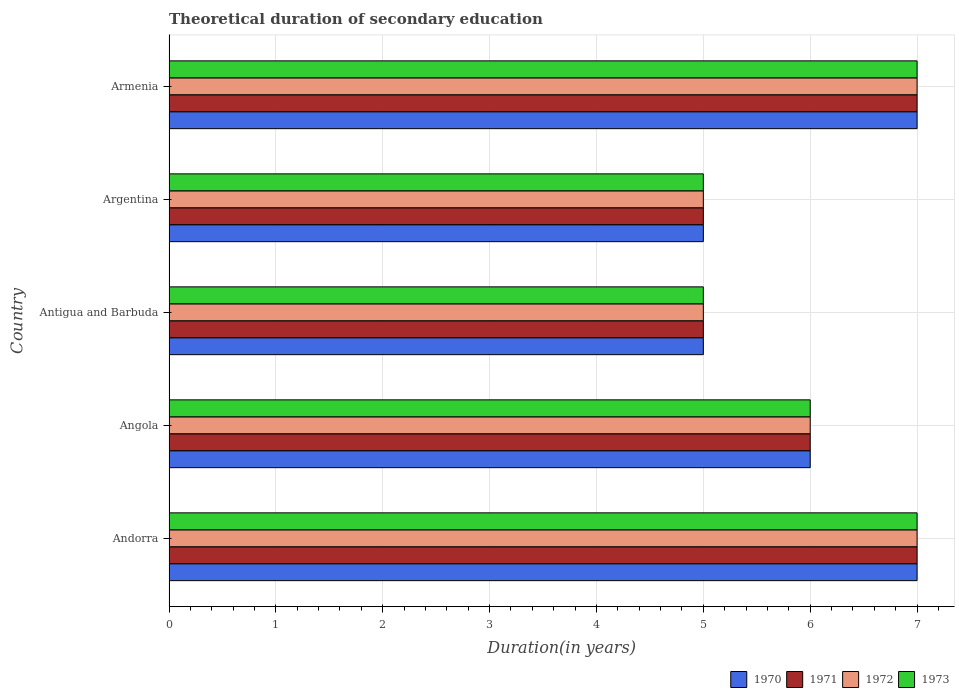How many different coloured bars are there?
Give a very brief answer. 4. How many groups of bars are there?
Your answer should be compact. 5. Are the number of bars on each tick of the Y-axis equal?
Provide a succinct answer. Yes. How many bars are there on the 5th tick from the bottom?
Ensure brevity in your answer.  4. What is the label of the 3rd group of bars from the top?
Provide a short and direct response. Antigua and Barbuda. Across all countries, what is the minimum total theoretical duration of secondary education in 1972?
Keep it short and to the point. 5. In which country was the total theoretical duration of secondary education in 1972 maximum?
Keep it short and to the point. Andorra. In which country was the total theoretical duration of secondary education in 1971 minimum?
Make the answer very short. Antigua and Barbuda. What is the difference between the total theoretical duration of secondary education in 1970 in Andorra and that in Antigua and Barbuda?
Provide a short and direct response. 2. What is the difference between the total theoretical duration of secondary education in 1971 in Armenia and the total theoretical duration of secondary education in 1972 in Antigua and Barbuda?
Your answer should be very brief. 2. What is the average total theoretical duration of secondary education in 1973 per country?
Give a very brief answer. 6. In how many countries, is the total theoretical duration of secondary education in 1971 greater than 4.8 years?
Ensure brevity in your answer.  5. What is the ratio of the total theoretical duration of secondary education in 1970 in Antigua and Barbuda to that in Armenia?
Your response must be concise. 0.71. Is the total theoretical duration of secondary education in 1972 in Andorra less than that in Argentina?
Ensure brevity in your answer.  No. What is the difference between the highest and the second highest total theoretical duration of secondary education in 1973?
Your answer should be compact. 0. What is the difference between the highest and the lowest total theoretical duration of secondary education in 1970?
Your answer should be compact. 2. In how many countries, is the total theoretical duration of secondary education in 1971 greater than the average total theoretical duration of secondary education in 1971 taken over all countries?
Offer a very short reply. 2. Is the sum of the total theoretical duration of secondary education in 1970 in Andorra and Argentina greater than the maximum total theoretical duration of secondary education in 1972 across all countries?
Your response must be concise. Yes. Is it the case that in every country, the sum of the total theoretical duration of secondary education in 1971 and total theoretical duration of secondary education in 1973 is greater than the sum of total theoretical duration of secondary education in 1970 and total theoretical duration of secondary education in 1972?
Offer a terse response. No. How many bars are there?
Offer a very short reply. 20. Are all the bars in the graph horizontal?
Ensure brevity in your answer.  Yes. Does the graph contain grids?
Ensure brevity in your answer.  Yes. Where does the legend appear in the graph?
Your answer should be compact. Bottom right. How are the legend labels stacked?
Make the answer very short. Horizontal. What is the title of the graph?
Provide a succinct answer. Theoretical duration of secondary education. Does "2013" appear as one of the legend labels in the graph?
Your answer should be very brief. No. What is the label or title of the X-axis?
Ensure brevity in your answer.  Duration(in years). What is the Duration(in years) of 1972 in Andorra?
Your answer should be very brief. 7. What is the Duration(in years) in 1973 in Andorra?
Your response must be concise. 7. What is the Duration(in years) of 1970 in Angola?
Your answer should be compact. 6. What is the Duration(in years) in 1972 in Angola?
Offer a terse response. 6. What is the Duration(in years) in 1971 in Antigua and Barbuda?
Your answer should be compact. 5. What is the Duration(in years) of 1972 in Antigua and Barbuda?
Give a very brief answer. 5. What is the Duration(in years) in 1973 in Antigua and Barbuda?
Your answer should be very brief. 5. What is the Duration(in years) of 1972 in Argentina?
Your answer should be very brief. 5. Across all countries, what is the maximum Duration(in years) of 1970?
Offer a terse response. 7. Across all countries, what is the maximum Duration(in years) of 1973?
Your response must be concise. 7. Across all countries, what is the minimum Duration(in years) in 1971?
Ensure brevity in your answer.  5. Across all countries, what is the minimum Duration(in years) in 1972?
Keep it short and to the point. 5. Across all countries, what is the minimum Duration(in years) in 1973?
Ensure brevity in your answer.  5. What is the total Duration(in years) in 1970 in the graph?
Make the answer very short. 30. What is the total Duration(in years) of 1972 in the graph?
Your answer should be compact. 30. What is the total Duration(in years) of 1973 in the graph?
Offer a terse response. 30. What is the difference between the Duration(in years) of 1970 in Andorra and that in Angola?
Your response must be concise. 1. What is the difference between the Duration(in years) of 1971 in Andorra and that in Angola?
Make the answer very short. 1. What is the difference between the Duration(in years) in 1972 in Andorra and that in Angola?
Keep it short and to the point. 1. What is the difference between the Duration(in years) in 1973 in Andorra and that in Antigua and Barbuda?
Keep it short and to the point. 2. What is the difference between the Duration(in years) of 1970 in Andorra and that in Argentina?
Your response must be concise. 2. What is the difference between the Duration(in years) in 1973 in Andorra and that in Argentina?
Provide a short and direct response. 2. What is the difference between the Duration(in years) of 1972 in Andorra and that in Armenia?
Offer a terse response. 0. What is the difference between the Duration(in years) of 1973 in Andorra and that in Armenia?
Make the answer very short. 0. What is the difference between the Duration(in years) in 1973 in Angola and that in Antigua and Barbuda?
Provide a short and direct response. 1. What is the difference between the Duration(in years) in 1970 in Angola and that in Armenia?
Offer a very short reply. -1. What is the difference between the Duration(in years) of 1972 in Angola and that in Armenia?
Offer a terse response. -1. What is the difference between the Duration(in years) in 1970 in Antigua and Barbuda and that in Argentina?
Make the answer very short. 0. What is the difference between the Duration(in years) in 1971 in Antigua and Barbuda and that in Argentina?
Your answer should be compact. 0. What is the difference between the Duration(in years) in 1972 in Antigua and Barbuda and that in Argentina?
Keep it short and to the point. 0. What is the difference between the Duration(in years) of 1970 in Antigua and Barbuda and that in Armenia?
Your answer should be very brief. -2. What is the difference between the Duration(in years) of 1970 in Argentina and that in Armenia?
Your answer should be very brief. -2. What is the difference between the Duration(in years) of 1970 in Andorra and the Duration(in years) of 1971 in Angola?
Offer a very short reply. 1. What is the difference between the Duration(in years) of 1970 in Andorra and the Duration(in years) of 1973 in Angola?
Make the answer very short. 1. What is the difference between the Duration(in years) in 1972 in Andorra and the Duration(in years) in 1973 in Angola?
Your answer should be very brief. 1. What is the difference between the Duration(in years) in 1970 in Andorra and the Duration(in years) in 1973 in Antigua and Barbuda?
Provide a short and direct response. 2. What is the difference between the Duration(in years) of 1971 in Andorra and the Duration(in years) of 1973 in Antigua and Barbuda?
Your answer should be compact. 2. What is the difference between the Duration(in years) of 1972 in Andorra and the Duration(in years) of 1973 in Antigua and Barbuda?
Your response must be concise. 2. What is the difference between the Duration(in years) of 1970 in Andorra and the Duration(in years) of 1971 in Argentina?
Offer a very short reply. 2. What is the difference between the Duration(in years) of 1971 in Andorra and the Duration(in years) of 1972 in Argentina?
Provide a succinct answer. 2. What is the difference between the Duration(in years) of 1971 in Andorra and the Duration(in years) of 1973 in Argentina?
Make the answer very short. 2. What is the difference between the Duration(in years) of 1972 in Andorra and the Duration(in years) of 1973 in Argentina?
Offer a very short reply. 2. What is the difference between the Duration(in years) of 1970 in Andorra and the Duration(in years) of 1971 in Armenia?
Your answer should be very brief. 0. What is the difference between the Duration(in years) of 1970 in Andorra and the Duration(in years) of 1972 in Armenia?
Provide a short and direct response. 0. What is the difference between the Duration(in years) in 1970 in Andorra and the Duration(in years) in 1973 in Armenia?
Offer a terse response. 0. What is the difference between the Duration(in years) of 1971 in Andorra and the Duration(in years) of 1973 in Armenia?
Ensure brevity in your answer.  0. What is the difference between the Duration(in years) of 1971 in Angola and the Duration(in years) of 1973 in Antigua and Barbuda?
Your answer should be compact. 1. What is the difference between the Duration(in years) of 1972 in Angola and the Duration(in years) of 1973 in Antigua and Barbuda?
Offer a very short reply. 1. What is the difference between the Duration(in years) in 1971 in Angola and the Duration(in years) in 1972 in Argentina?
Provide a short and direct response. 1. What is the difference between the Duration(in years) of 1970 in Angola and the Duration(in years) of 1971 in Armenia?
Keep it short and to the point. -1. What is the difference between the Duration(in years) of 1970 in Angola and the Duration(in years) of 1972 in Armenia?
Provide a succinct answer. -1. What is the difference between the Duration(in years) in 1970 in Angola and the Duration(in years) in 1973 in Armenia?
Provide a succinct answer. -1. What is the difference between the Duration(in years) of 1971 in Angola and the Duration(in years) of 1972 in Armenia?
Your answer should be compact. -1. What is the difference between the Duration(in years) in 1970 in Antigua and Barbuda and the Duration(in years) in 1971 in Argentina?
Keep it short and to the point. 0. What is the difference between the Duration(in years) of 1970 in Antigua and Barbuda and the Duration(in years) of 1972 in Argentina?
Your response must be concise. 0. What is the difference between the Duration(in years) in 1970 in Antigua and Barbuda and the Duration(in years) in 1973 in Argentina?
Your response must be concise. 0. What is the difference between the Duration(in years) in 1971 in Antigua and Barbuda and the Duration(in years) in 1972 in Argentina?
Ensure brevity in your answer.  0. What is the difference between the Duration(in years) of 1972 in Antigua and Barbuda and the Duration(in years) of 1973 in Argentina?
Your response must be concise. 0. What is the difference between the Duration(in years) in 1970 in Antigua and Barbuda and the Duration(in years) in 1971 in Armenia?
Your answer should be compact. -2. What is the difference between the Duration(in years) in 1971 in Antigua and Barbuda and the Duration(in years) in 1972 in Armenia?
Ensure brevity in your answer.  -2. What is the difference between the Duration(in years) of 1971 in Antigua and Barbuda and the Duration(in years) of 1973 in Armenia?
Your response must be concise. -2. What is the difference between the Duration(in years) in 1970 in Argentina and the Duration(in years) in 1973 in Armenia?
Offer a very short reply. -2. What is the average Duration(in years) of 1971 per country?
Keep it short and to the point. 6. What is the average Duration(in years) in 1973 per country?
Ensure brevity in your answer.  6. What is the difference between the Duration(in years) in 1970 and Duration(in years) in 1971 in Andorra?
Offer a terse response. 0. What is the difference between the Duration(in years) in 1971 and Duration(in years) in 1972 in Andorra?
Make the answer very short. 0. What is the difference between the Duration(in years) in 1971 and Duration(in years) in 1973 in Andorra?
Provide a short and direct response. 0. What is the difference between the Duration(in years) of 1972 and Duration(in years) of 1973 in Andorra?
Make the answer very short. 0. What is the difference between the Duration(in years) of 1970 and Duration(in years) of 1973 in Angola?
Provide a succinct answer. 0. What is the difference between the Duration(in years) in 1972 and Duration(in years) in 1973 in Angola?
Your response must be concise. 0. What is the difference between the Duration(in years) in 1970 and Duration(in years) in 1971 in Antigua and Barbuda?
Ensure brevity in your answer.  0. What is the difference between the Duration(in years) of 1970 and Duration(in years) of 1973 in Antigua and Barbuda?
Your answer should be compact. 0. What is the difference between the Duration(in years) in 1971 and Duration(in years) in 1973 in Antigua and Barbuda?
Ensure brevity in your answer.  0. What is the difference between the Duration(in years) of 1970 and Duration(in years) of 1972 in Argentina?
Ensure brevity in your answer.  0. What is the difference between the Duration(in years) of 1971 and Duration(in years) of 1972 in Argentina?
Offer a terse response. 0. What is the difference between the Duration(in years) in 1970 and Duration(in years) in 1971 in Armenia?
Make the answer very short. 0. What is the difference between the Duration(in years) in 1970 and Duration(in years) in 1972 in Armenia?
Provide a succinct answer. 0. What is the difference between the Duration(in years) of 1971 and Duration(in years) of 1973 in Armenia?
Make the answer very short. 0. What is the difference between the Duration(in years) of 1972 and Duration(in years) of 1973 in Armenia?
Offer a terse response. 0. What is the ratio of the Duration(in years) of 1973 in Andorra to that in Angola?
Offer a very short reply. 1.17. What is the ratio of the Duration(in years) of 1970 in Andorra to that in Antigua and Barbuda?
Keep it short and to the point. 1.4. What is the ratio of the Duration(in years) in 1971 in Andorra to that in Antigua and Barbuda?
Provide a succinct answer. 1.4. What is the ratio of the Duration(in years) of 1972 in Andorra to that in Antigua and Barbuda?
Provide a succinct answer. 1.4. What is the ratio of the Duration(in years) in 1973 in Andorra to that in Antigua and Barbuda?
Offer a terse response. 1.4. What is the ratio of the Duration(in years) in 1970 in Andorra to that in Argentina?
Provide a short and direct response. 1.4. What is the ratio of the Duration(in years) in 1971 in Andorra to that in Argentina?
Provide a succinct answer. 1.4. What is the ratio of the Duration(in years) of 1972 in Andorra to that in Argentina?
Your answer should be compact. 1.4. What is the ratio of the Duration(in years) in 1973 in Andorra to that in Argentina?
Your response must be concise. 1.4. What is the ratio of the Duration(in years) in 1970 in Andorra to that in Armenia?
Your answer should be very brief. 1. What is the ratio of the Duration(in years) of 1971 in Andorra to that in Armenia?
Provide a succinct answer. 1. What is the ratio of the Duration(in years) in 1972 in Andorra to that in Armenia?
Make the answer very short. 1. What is the ratio of the Duration(in years) in 1973 in Andorra to that in Armenia?
Make the answer very short. 1. What is the ratio of the Duration(in years) in 1970 in Angola to that in Antigua and Barbuda?
Offer a very short reply. 1.2. What is the ratio of the Duration(in years) of 1972 in Angola to that in Antigua and Barbuda?
Make the answer very short. 1.2. What is the ratio of the Duration(in years) in 1973 in Angola to that in Argentina?
Offer a terse response. 1.2. What is the ratio of the Duration(in years) in 1970 in Angola to that in Armenia?
Keep it short and to the point. 0.86. What is the ratio of the Duration(in years) of 1973 in Angola to that in Armenia?
Your answer should be compact. 0.86. What is the ratio of the Duration(in years) of 1972 in Antigua and Barbuda to that in Argentina?
Give a very brief answer. 1. What is the ratio of the Duration(in years) of 1973 in Antigua and Barbuda to that in Argentina?
Your response must be concise. 1. What is the ratio of the Duration(in years) in 1970 in Antigua and Barbuda to that in Armenia?
Make the answer very short. 0.71. What is the ratio of the Duration(in years) of 1971 in Antigua and Barbuda to that in Armenia?
Provide a short and direct response. 0.71. What is the ratio of the Duration(in years) in 1973 in Antigua and Barbuda to that in Armenia?
Make the answer very short. 0.71. What is the ratio of the Duration(in years) of 1972 in Argentina to that in Armenia?
Offer a very short reply. 0.71. What is the ratio of the Duration(in years) of 1973 in Argentina to that in Armenia?
Provide a succinct answer. 0.71. What is the difference between the highest and the second highest Duration(in years) of 1970?
Offer a terse response. 0. What is the difference between the highest and the second highest Duration(in years) in 1971?
Provide a short and direct response. 0. What is the difference between the highest and the lowest Duration(in years) in 1970?
Offer a very short reply. 2. What is the difference between the highest and the lowest Duration(in years) in 1972?
Your answer should be compact. 2. 